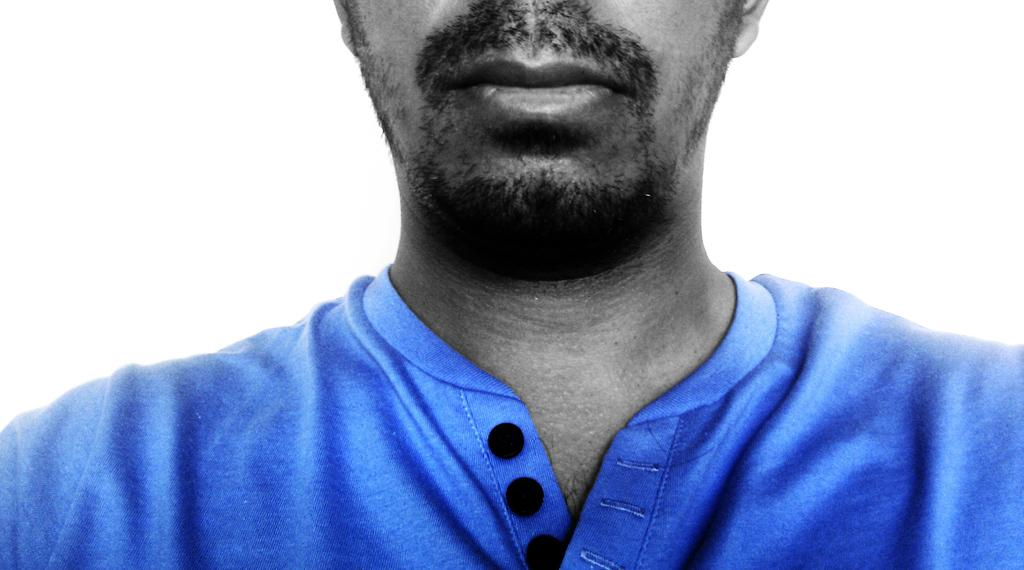What is present in the image? There is a person in the image. What is the person wearing? The person is wearing a blue color t-shirt. What is the color of the background in the image? The background of the image is white. What type of waste can be seen in the image? There is no waste present in the image. What is the stitch pattern on the person's t-shirt in the image? The provided facts do not mention any specific stitch pattern on the t-shirt. --- 